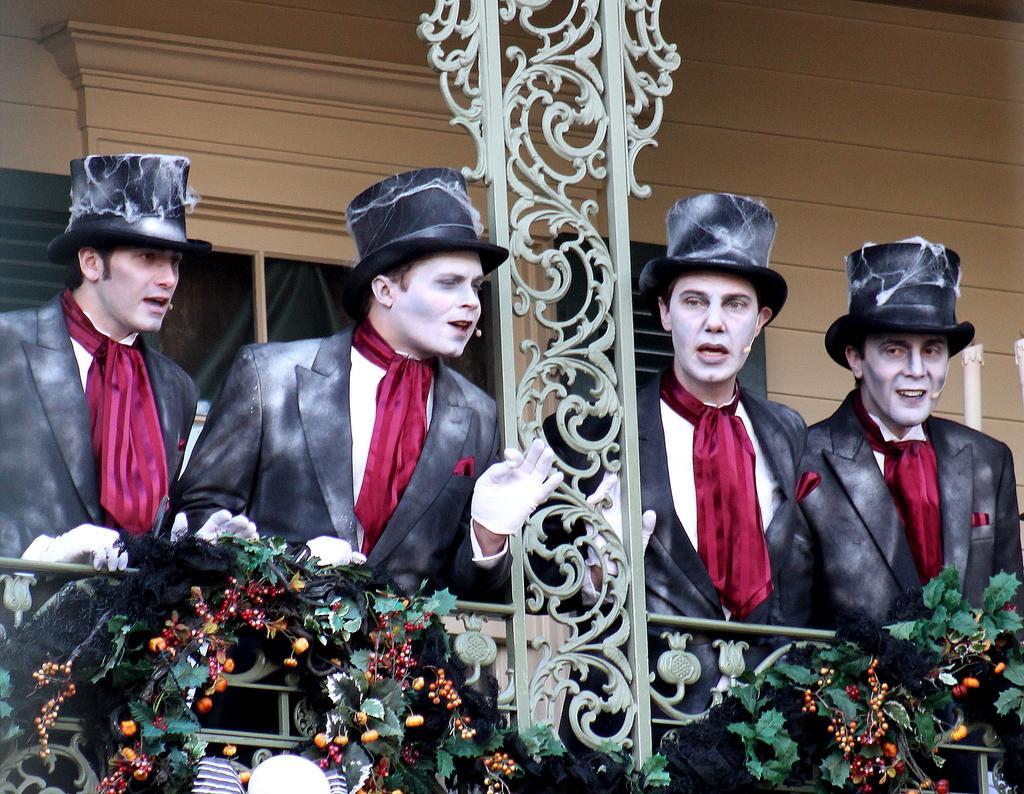In one or two sentences, can you explain what this image depicts? In this image, we can see people wearing costumes, caps and gloves and are wearing mics. In the background, there is a wall and we can see railings and some christmas ornaments. 